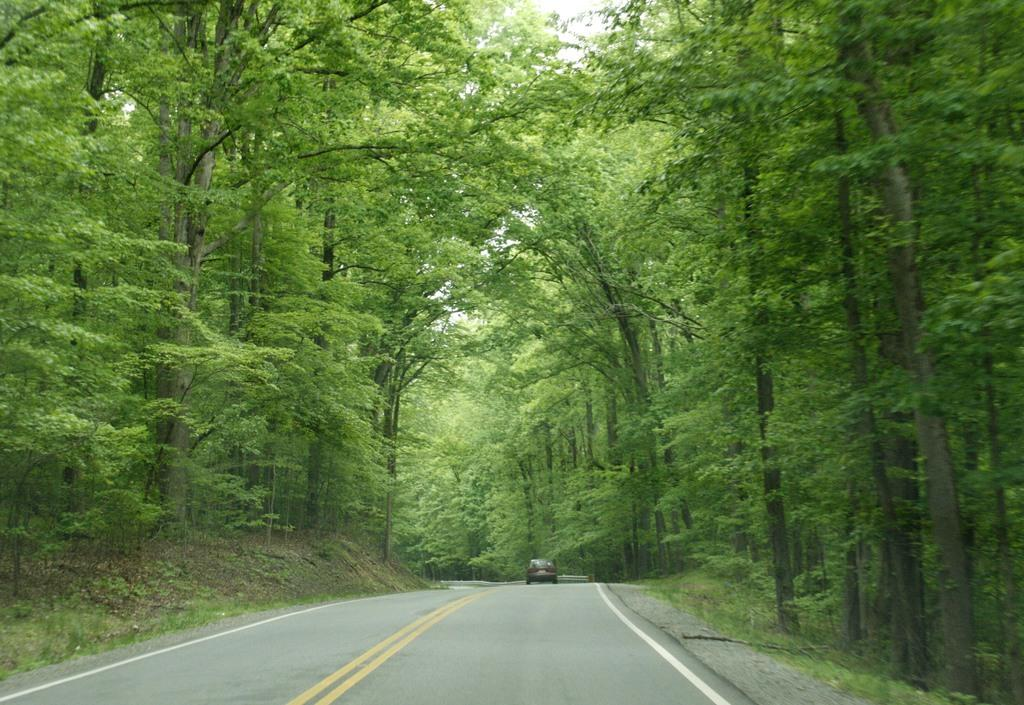What is the main subject in the image? There is a road in the image. What is present on the road? There is a car on the road. What can be seen on the sides of the road? There are trees on the sides of the road. Can you see a rabbit hopping along the road in the image? There is no rabbit hopping along the road in the image. How many cent-like creatures are holding the hands of the car in the image? There are no cent-like creatures or any hands holding the car in the image. 